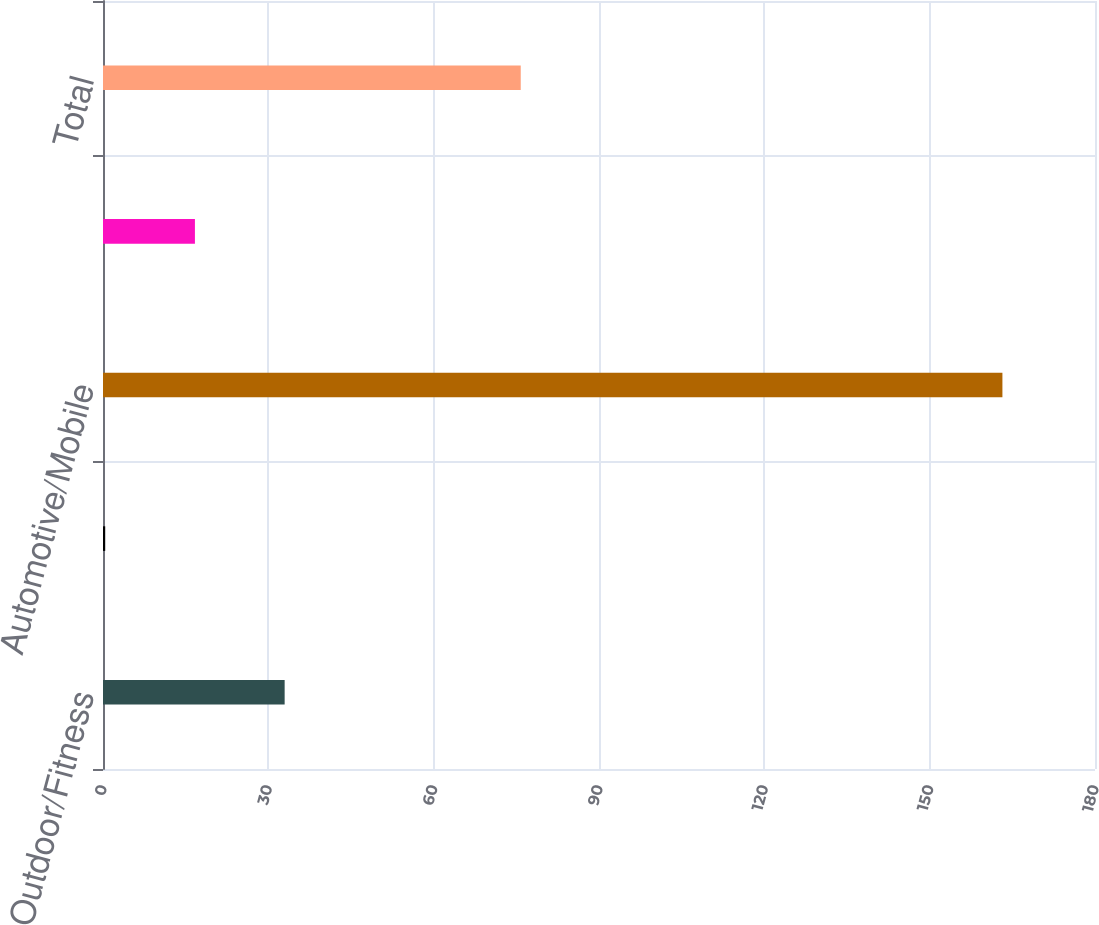Convert chart. <chart><loc_0><loc_0><loc_500><loc_500><bar_chart><fcel>Outdoor/Fitness<fcel>Marine<fcel>Automotive/Mobile<fcel>Aviation<fcel>Total<nl><fcel>32.96<fcel>0.4<fcel>163.2<fcel>16.68<fcel>75.8<nl></chart> 